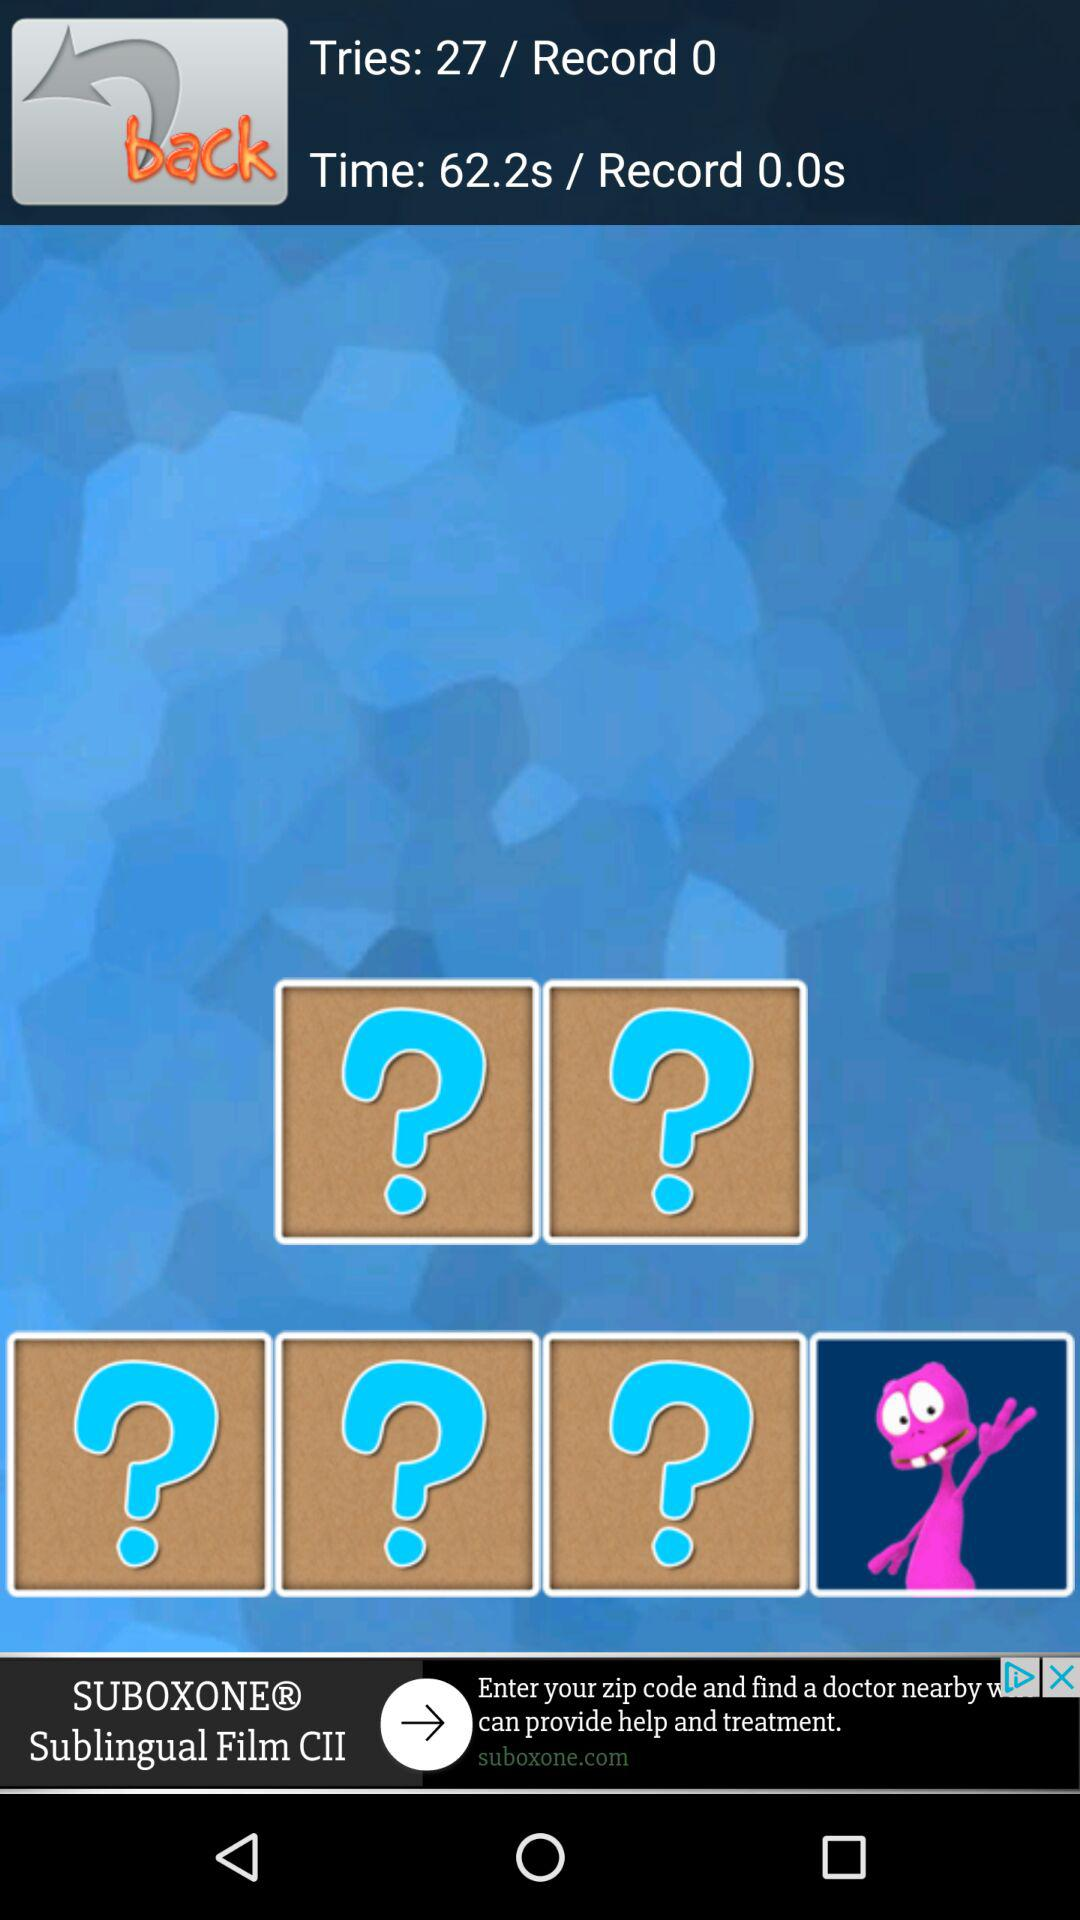What is the number in the record?
When the provided information is insufficient, respond with <no answer>. <no answer> 